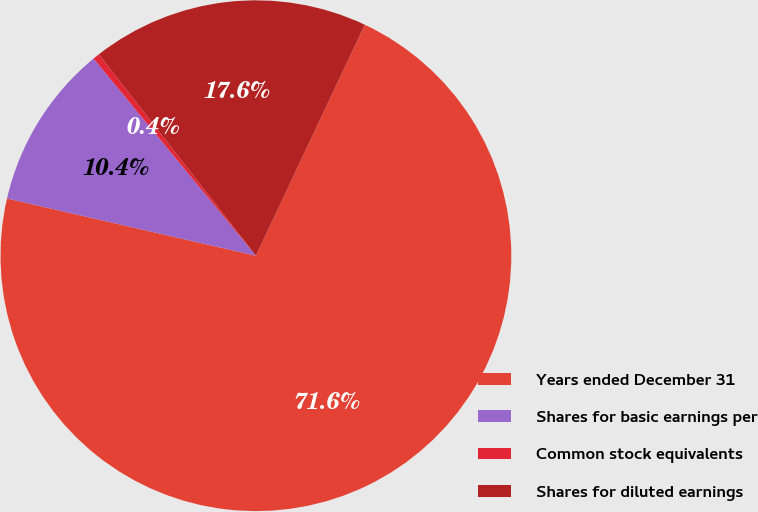Convert chart. <chart><loc_0><loc_0><loc_500><loc_500><pie_chart><fcel>Years ended December 31<fcel>Shares for basic earnings per<fcel>Common stock equivalents<fcel>Shares for diluted earnings<nl><fcel>71.59%<fcel>10.44%<fcel>0.42%<fcel>17.56%<nl></chart> 